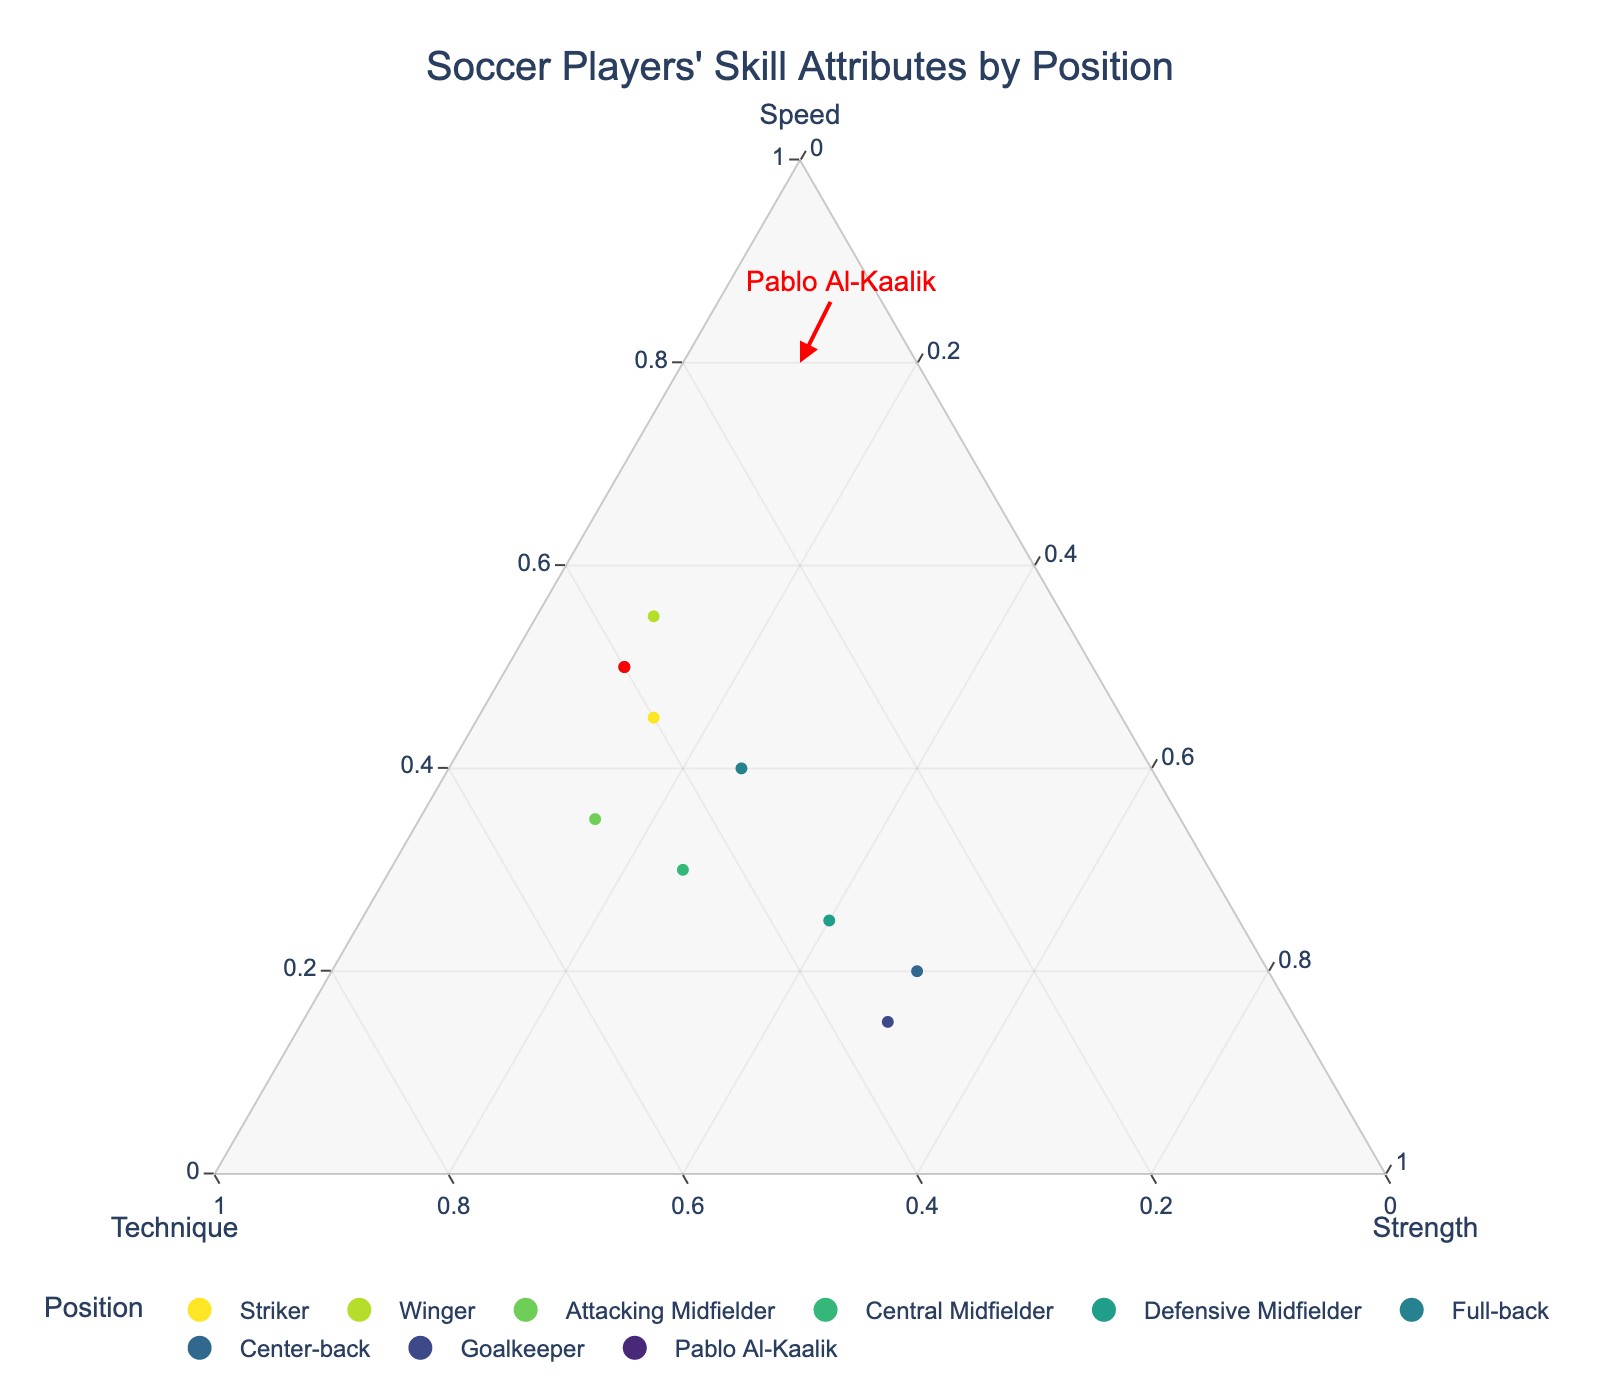What is the title of the figure? The title is usually displayed prominently at the top of the figure. In this case, it is stated in the code under the `title` attribute while creating the ternary plot.
Answer: Soccer Players' Skill Attributes by Position How many positions are represented in the figure? The figure includes several positions, each represented by a unique data point. From the data provided, there are 8 different positions plus Pablo Al-Kaalik, making a total of 9 positions.
Answer: 9 Which position has the highest value of speed? To determine which position has the highest speed, we need to look at the speed values. From the data, the winger has the highest speed value of 0.55.
Answer: Winger Which position has the highest strength attribute? Check the strength values in the data. Both the center-back and goalkeeper share the highest strength value of 0.50.
Answer: Center-back and Goalkeeper What is the sum of the technique and strength attributes for an Attacking Midfielder? We sum up the technique (0.50) and strength (0.15) values for the Attacking Midfielder. The sum is 0.50 + 0.15 = 0.65.
Answer: 0.65 How does Pablo Al-Kaalik's attribute composition compare to a Winger's? Compare the values of speed, technique, and strength for both. Pablo's attributes are 0.50 speed, 0.40 technique, 0.10 strength, while the Winger's are 0.55 speed, 0.35 technique, 0.10 strength. Pablo has higher technique, while the Winger has higher speed; both have the same strength.
Answer: Pablo has higher technique; Winger has higher speed; both same strength Which position is closest to Pablo Al-Kaalik in terms of attribute composition? Look for the position whose attribute values are closest to Pablo Al-Kaalik’s (0.50, 0.40, 0.10). The Striker (0.45, 0.40, 0.15) has a very similar composition, making it the closest.
Answer: Striker What is the range of the strength attribute values across all positions? Find the minimum and maximum values of the strength attribute from the data. The minimum strength value is 0.10 (Winger), and the maximum is 0.50 (Center-back, Goalkeeper). The range is 0.50 - 0.10 = 0.40.
Answer: 0.40 Which position has the lowest technique value? To determine this, check the technique values for each position. The Center-back has the lowest technique value of 0.30.
Answer: Center-back 